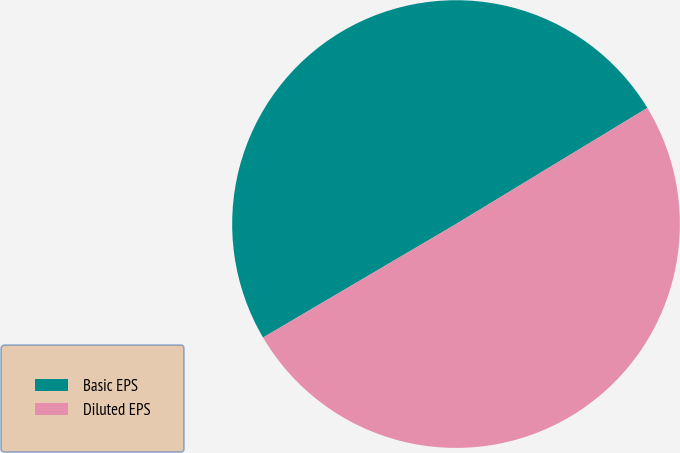<chart> <loc_0><loc_0><loc_500><loc_500><pie_chart><fcel>Basic EPS<fcel>Diluted EPS<nl><fcel>49.78%<fcel>50.22%<nl></chart> 